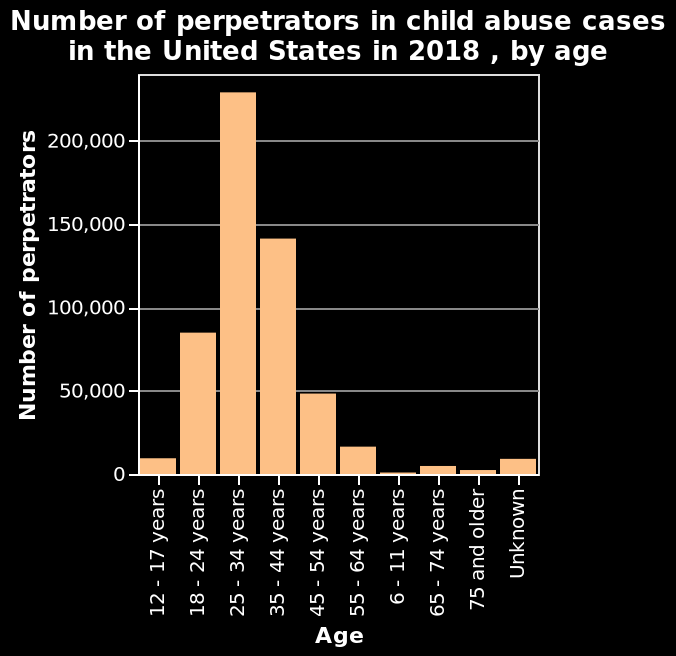<image>
What is the most common age bracket among child abuse perpetrators? Among child abuse perpetrators, the most common age bracket is 25-34 years old. 